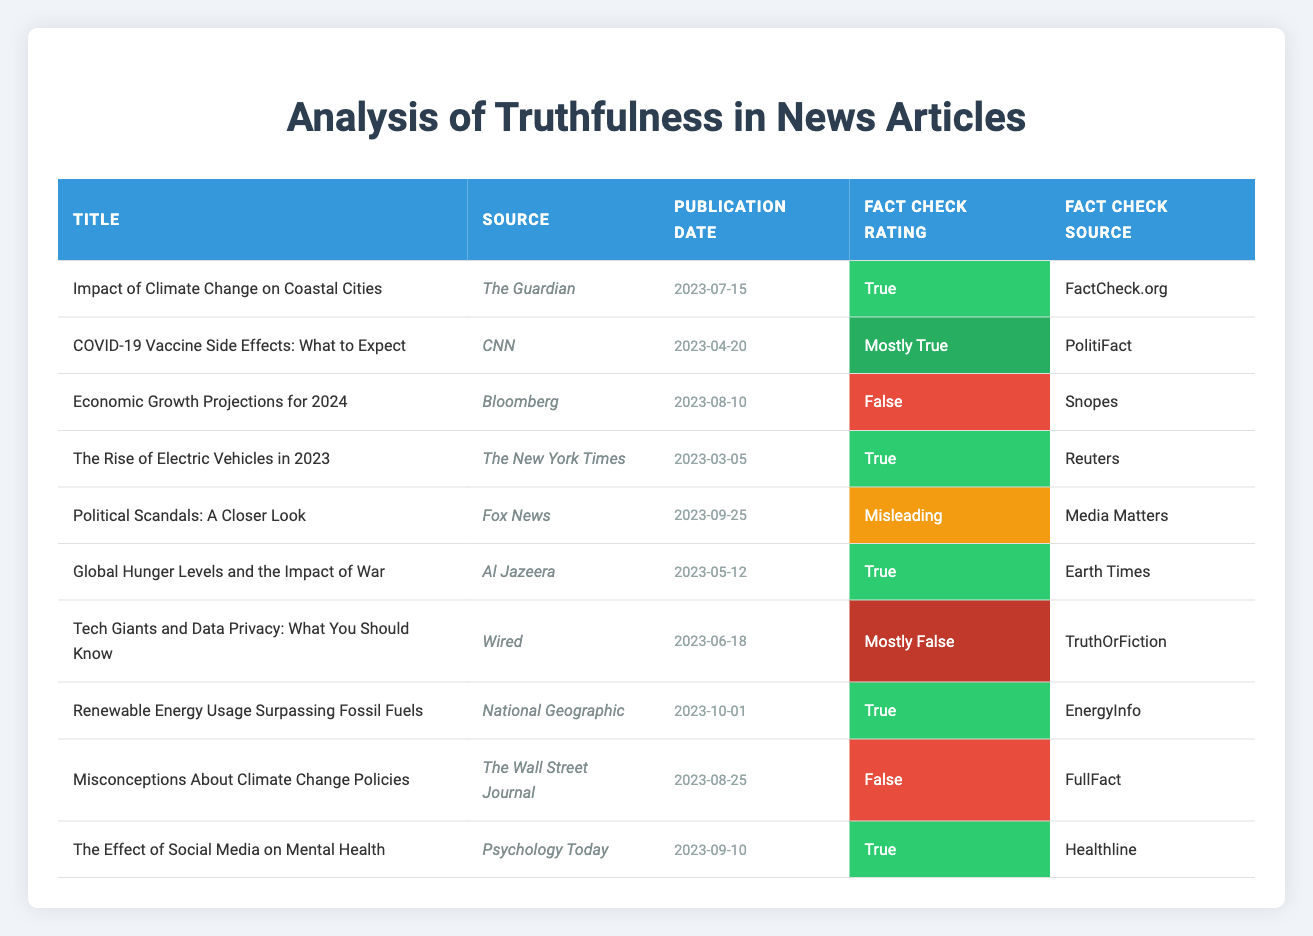What is the title of the article published by The Guardian? The table lists all articles along with their respective details. Looking at the row for The Guardian, the title is "Impact of Climate Change on Coastal Cities."
Answer: Impact of Climate Change on Coastal Cities Which article has a fact check rating of "Mostly False"? I can check the fact check ratings in the table. The article with the "Mostly False" rating is "Tech Giants and Data Privacy: What You Should Know," published by Wired.
Answer: Tech Giants and Data Privacy: What You Should Know How many articles have a fact check rating of "True"? Counting the rows marked with "True," I see that there are four articles: "Impact of Climate Change on Coastal Cities," "The Rise of Electric Vehicles in 2023," "Global Hunger Levels and the Impact of War," and "The Effect of Social Media on Mental Health."
Answer: 4 Is there an article titled "Economic Growth Projections for 2024"? The table can be scanned for the title "Economic Growth Projections for 2024," and it is present, confirming that there is indeed such an article.
Answer: Yes What percentage of the articles are rated "False"? There are 10 articles in total, and 2 of them are rated "False." Calculating the percentage: (2/10) * 100 = 20%.
Answer: 20% Is the publication date for "Renewable Energy Usage Surpassing Fossil Fuels" before "Economic Growth Projections for 2024"? I compare the publication dates in the table. "Renewable Energy Usage Surpassing Fossil Fuels" is dated 2023-10-01 and "Economic Growth Projections for 2024" is dated 2023-08-10. Since October is after August, the date for the former is not before the latter.
Answer: No How many articles from CNN have a "Mostly True" rating compared to others? The table shows that CNN has one article rated "Mostly True," and to see if others have more, I observe that no other outlet has more — CNN stands as the only one so rated.
Answer: 1 Which article has the most recent publication date? Analyzing the publication dates, the latest one is for "Renewable Energy Usage Surpassing Fossil Fuels," published on 2023-10-01.
Answer: Renewable Energy Usage Surpassing Fossil Fuels 